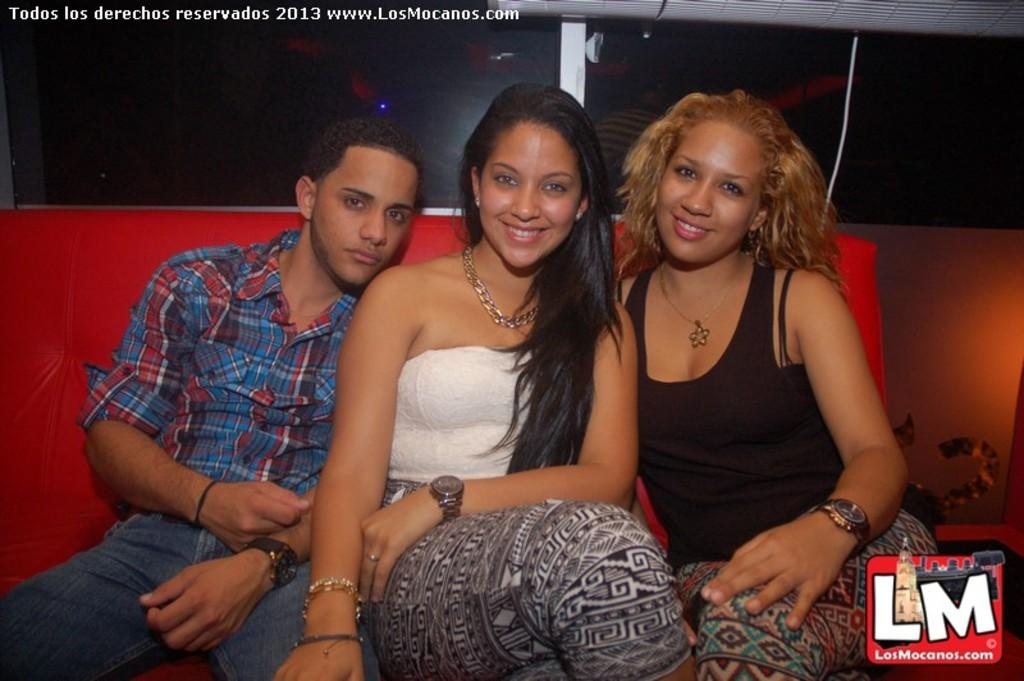How many people are in the image? There are three people in the image. What are the people doing in the image? The people are sitting on a sofa and posing for a photo. What type of advertisement can be seen in the background of the image? There is no advertisement present in the image; it only shows three people sitting on a sofa and posing for a photo. 